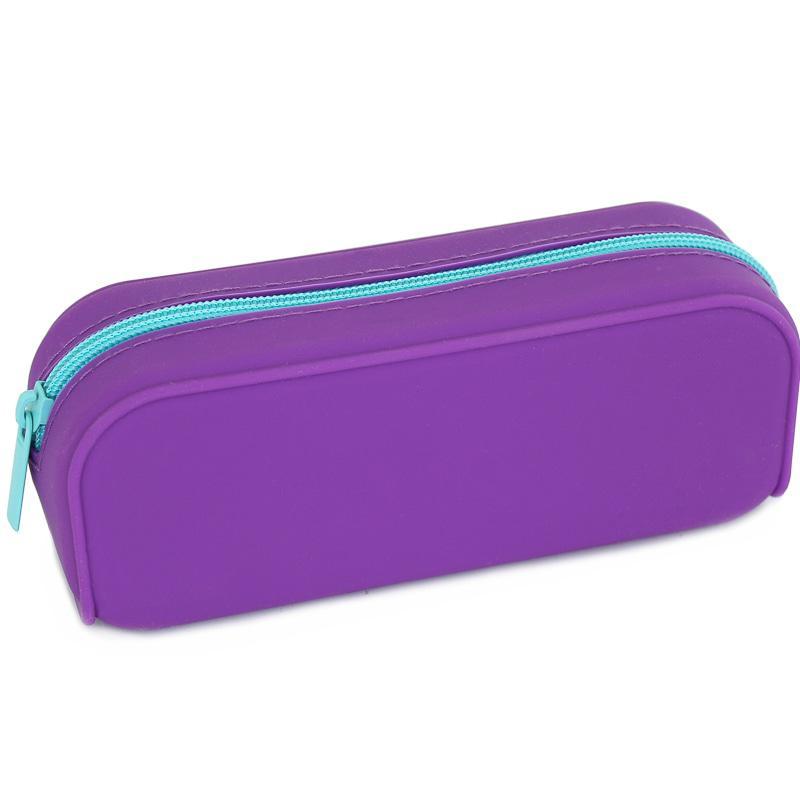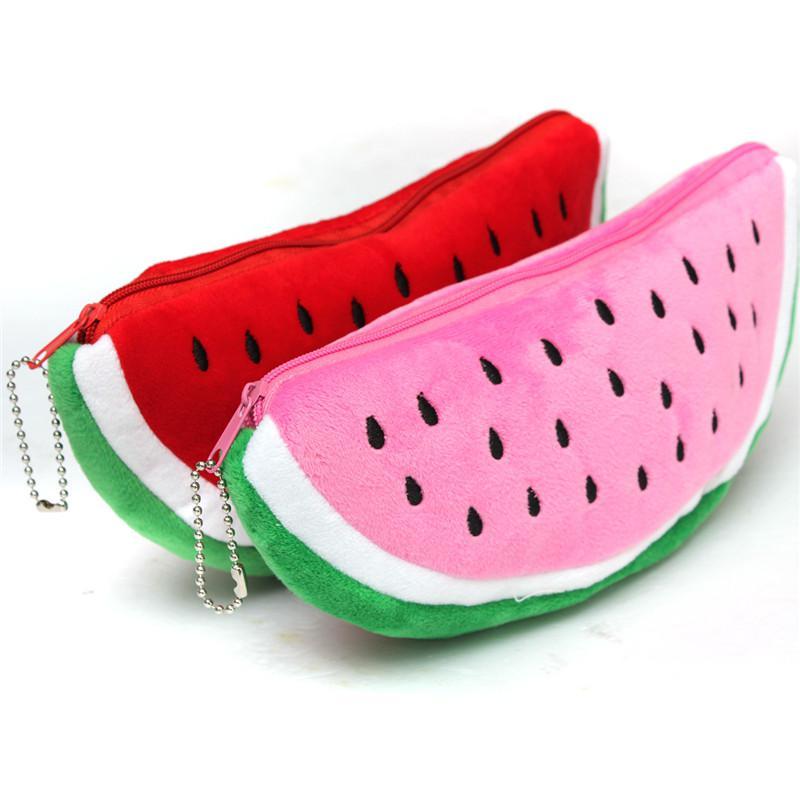The first image is the image on the left, the second image is the image on the right. Given the left and right images, does the statement "One of the cases looks like a watermelon slice with a turquoise-blue rind." hold true? Answer yes or no. No. The first image is the image on the left, the second image is the image on the right. Analyze the images presented: Is the assertion "The bag in the image on the left is shaped like a watermelon." valid? Answer yes or no. No. 